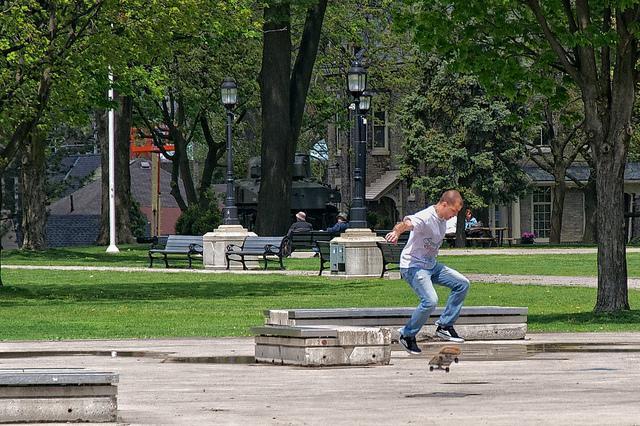How many benches can be seen?
Give a very brief answer. 2. 